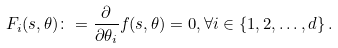Convert formula to latex. <formula><loc_0><loc_0><loc_500><loc_500>F _ { i } ( s , \theta ) \colon = \frac { \partial } { \partial \theta _ { i } } f ( s , \theta ) = 0 , \forall i \in \{ 1 , 2 , \dots , d \} \, .</formula> 